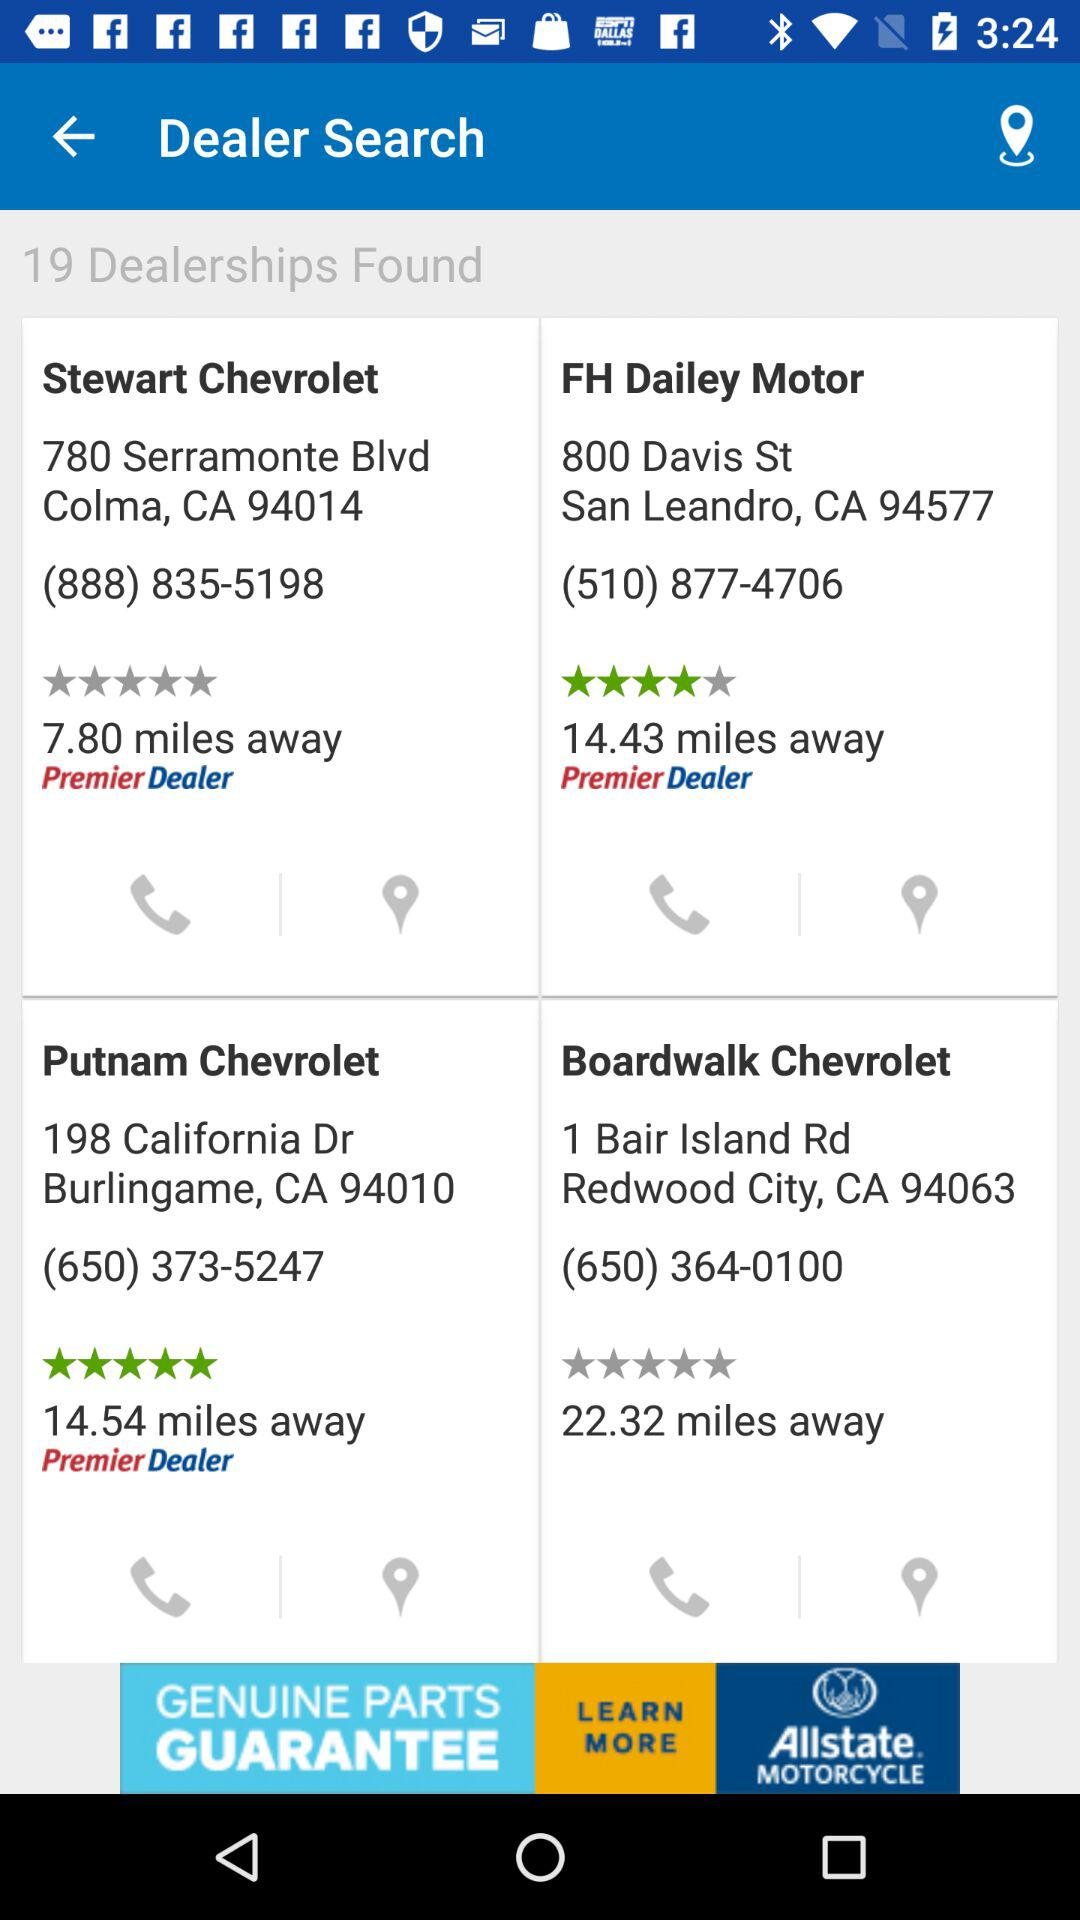What is the number of dealerships found? The number of dealerships found is 19. 